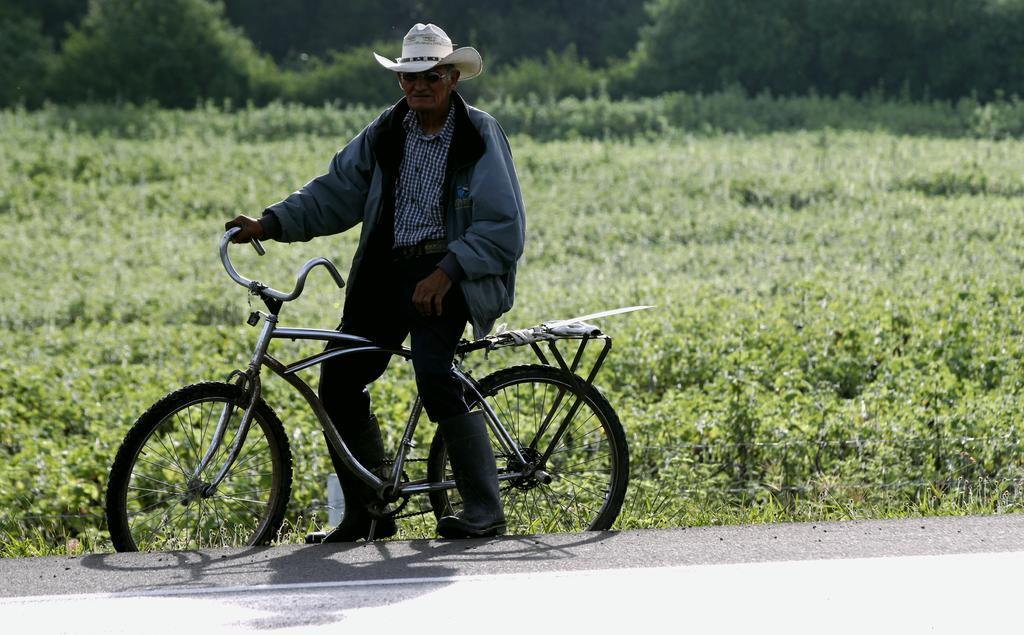How would you summarize this image in a sentence or two? This is the picture outside of the city. In this image there is a person with a jacket and black boots and white hat, He is sitting on the bicycle beside the road. At the back there are plants and trees. 